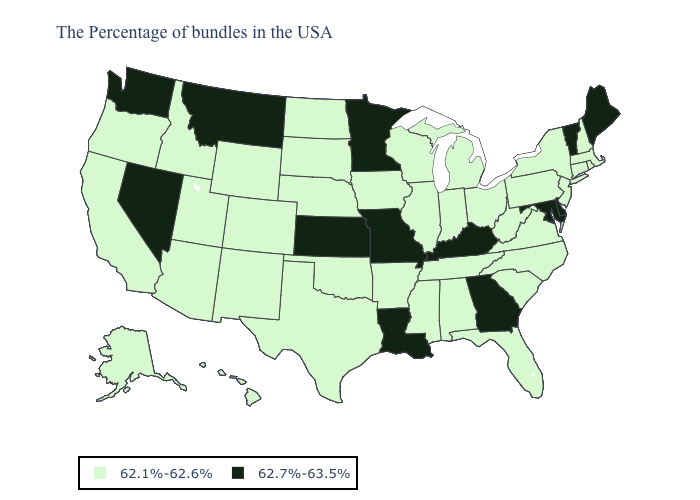What is the value of Georgia?
Write a very short answer. 62.7%-63.5%. What is the value of Arizona?
Short answer required. 62.1%-62.6%. What is the lowest value in the USA?
Short answer required. 62.1%-62.6%. Among the states that border Nebraska , does Wyoming have the highest value?
Keep it brief. No. Which states hav the highest value in the MidWest?
Quick response, please. Missouri, Minnesota, Kansas. Does Texas have the highest value in the USA?
Short answer required. No. What is the value of Pennsylvania?
Short answer required. 62.1%-62.6%. Name the states that have a value in the range 62.7%-63.5%?
Answer briefly. Maine, Vermont, Delaware, Maryland, Georgia, Kentucky, Louisiana, Missouri, Minnesota, Kansas, Montana, Nevada, Washington. Name the states that have a value in the range 62.7%-63.5%?
Write a very short answer. Maine, Vermont, Delaware, Maryland, Georgia, Kentucky, Louisiana, Missouri, Minnesota, Kansas, Montana, Nevada, Washington. What is the value of Delaware?
Write a very short answer. 62.7%-63.5%. Which states have the lowest value in the South?
Write a very short answer. Virginia, North Carolina, South Carolina, West Virginia, Florida, Alabama, Tennessee, Mississippi, Arkansas, Oklahoma, Texas. Among the states that border Maryland , which have the lowest value?
Quick response, please. Pennsylvania, Virginia, West Virginia. Does New Mexico have the highest value in the West?
Answer briefly. No. Does the first symbol in the legend represent the smallest category?
Concise answer only. Yes. Does Tennessee have the lowest value in the USA?
Be succinct. Yes. 